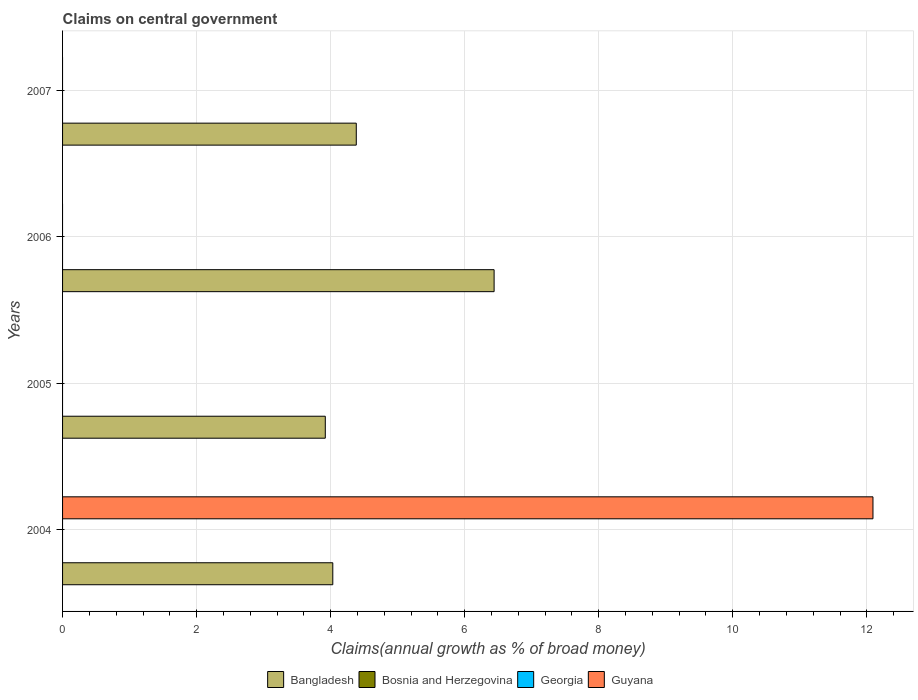How many bars are there on the 1st tick from the top?
Offer a terse response. 1. What is the label of the 2nd group of bars from the top?
Your response must be concise. 2006. In how many cases, is the number of bars for a given year not equal to the number of legend labels?
Provide a short and direct response. 4. What is the percentage of broad money claimed on centeral government in Georgia in 2004?
Provide a succinct answer. 0. Across all years, what is the maximum percentage of broad money claimed on centeral government in Bangladesh?
Provide a short and direct response. 6.44. Across all years, what is the minimum percentage of broad money claimed on centeral government in Bangladesh?
Provide a succinct answer. 3.92. What is the total percentage of broad money claimed on centeral government in Bangladesh in the graph?
Your answer should be very brief. 18.77. What is the difference between the percentage of broad money claimed on centeral government in Bangladesh in 2006 and that in 2007?
Your answer should be compact. 2.06. What is the average percentage of broad money claimed on centeral government in Bangladesh per year?
Give a very brief answer. 4.69. What is the ratio of the percentage of broad money claimed on centeral government in Bangladesh in 2004 to that in 2005?
Your response must be concise. 1.03. What is the difference between the highest and the second highest percentage of broad money claimed on centeral government in Bangladesh?
Provide a succinct answer. 2.06. What is the difference between the highest and the lowest percentage of broad money claimed on centeral government in Guyana?
Give a very brief answer. 12.09. In how many years, is the percentage of broad money claimed on centeral government in Bangladesh greater than the average percentage of broad money claimed on centeral government in Bangladesh taken over all years?
Provide a short and direct response. 1. Is the sum of the percentage of broad money claimed on centeral government in Bangladesh in 2005 and 2006 greater than the maximum percentage of broad money claimed on centeral government in Bosnia and Herzegovina across all years?
Offer a very short reply. Yes. Is it the case that in every year, the sum of the percentage of broad money claimed on centeral government in Guyana and percentage of broad money claimed on centeral government in Georgia is greater than the percentage of broad money claimed on centeral government in Bosnia and Herzegovina?
Ensure brevity in your answer.  No. How many bars are there?
Provide a short and direct response. 5. Are all the bars in the graph horizontal?
Your answer should be compact. Yes. How many years are there in the graph?
Offer a terse response. 4. Are the values on the major ticks of X-axis written in scientific E-notation?
Your response must be concise. No. Does the graph contain any zero values?
Offer a very short reply. Yes. Does the graph contain grids?
Provide a succinct answer. Yes. How many legend labels are there?
Ensure brevity in your answer.  4. How are the legend labels stacked?
Provide a succinct answer. Horizontal. What is the title of the graph?
Your response must be concise. Claims on central government. What is the label or title of the X-axis?
Provide a succinct answer. Claims(annual growth as % of broad money). What is the Claims(annual growth as % of broad money) of Bangladesh in 2004?
Offer a terse response. 4.03. What is the Claims(annual growth as % of broad money) in Bosnia and Herzegovina in 2004?
Your answer should be compact. 0. What is the Claims(annual growth as % of broad money) in Guyana in 2004?
Your response must be concise. 12.09. What is the Claims(annual growth as % of broad money) of Bangladesh in 2005?
Offer a terse response. 3.92. What is the Claims(annual growth as % of broad money) in Georgia in 2005?
Make the answer very short. 0. What is the Claims(annual growth as % of broad money) in Guyana in 2005?
Provide a short and direct response. 0. What is the Claims(annual growth as % of broad money) in Bangladesh in 2006?
Offer a terse response. 6.44. What is the Claims(annual growth as % of broad money) in Bosnia and Herzegovina in 2006?
Your response must be concise. 0. What is the Claims(annual growth as % of broad money) in Georgia in 2006?
Provide a succinct answer. 0. What is the Claims(annual growth as % of broad money) in Guyana in 2006?
Your response must be concise. 0. What is the Claims(annual growth as % of broad money) in Bangladesh in 2007?
Provide a succinct answer. 4.38. What is the Claims(annual growth as % of broad money) of Guyana in 2007?
Offer a very short reply. 0. Across all years, what is the maximum Claims(annual growth as % of broad money) in Bangladesh?
Keep it short and to the point. 6.44. Across all years, what is the maximum Claims(annual growth as % of broad money) in Guyana?
Provide a succinct answer. 12.09. Across all years, what is the minimum Claims(annual growth as % of broad money) in Bangladesh?
Offer a terse response. 3.92. Across all years, what is the minimum Claims(annual growth as % of broad money) of Guyana?
Make the answer very short. 0. What is the total Claims(annual growth as % of broad money) of Bangladesh in the graph?
Ensure brevity in your answer.  18.77. What is the total Claims(annual growth as % of broad money) of Guyana in the graph?
Offer a very short reply. 12.09. What is the difference between the Claims(annual growth as % of broad money) of Bangladesh in 2004 and that in 2005?
Give a very brief answer. 0.11. What is the difference between the Claims(annual growth as % of broad money) in Bangladesh in 2004 and that in 2006?
Make the answer very short. -2.41. What is the difference between the Claims(annual growth as % of broad money) of Bangladesh in 2004 and that in 2007?
Offer a terse response. -0.35. What is the difference between the Claims(annual growth as % of broad money) in Bangladesh in 2005 and that in 2006?
Your answer should be compact. -2.52. What is the difference between the Claims(annual growth as % of broad money) of Bangladesh in 2005 and that in 2007?
Provide a short and direct response. -0.46. What is the difference between the Claims(annual growth as % of broad money) in Bangladesh in 2006 and that in 2007?
Offer a terse response. 2.06. What is the average Claims(annual growth as % of broad money) in Bangladesh per year?
Ensure brevity in your answer.  4.69. What is the average Claims(annual growth as % of broad money) in Bosnia and Herzegovina per year?
Your response must be concise. 0. What is the average Claims(annual growth as % of broad money) in Guyana per year?
Ensure brevity in your answer.  3.02. In the year 2004, what is the difference between the Claims(annual growth as % of broad money) in Bangladesh and Claims(annual growth as % of broad money) in Guyana?
Provide a short and direct response. -8.06. What is the ratio of the Claims(annual growth as % of broad money) in Bangladesh in 2004 to that in 2005?
Ensure brevity in your answer.  1.03. What is the ratio of the Claims(annual growth as % of broad money) of Bangladesh in 2004 to that in 2006?
Provide a succinct answer. 0.63. What is the ratio of the Claims(annual growth as % of broad money) of Bangladesh in 2004 to that in 2007?
Provide a short and direct response. 0.92. What is the ratio of the Claims(annual growth as % of broad money) of Bangladesh in 2005 to that in 2006?
Your response must be concise. 0.61. What is the ratio of the Claims(annual growth as % of broad money) in Bangladesh in 2005 to that in 2007?
Offer a terse response. 0.89. What is the ratio of the Claims(annual growth as % of broad money) of Bangladesh in 2006 to that in 2007?
Keep it short and to the point. 1.47. What is the difference between the highest and the second highest Claims(annual growth as % of broad money) of Bangladesh?
Offer a terse response. 2.06. What is the difference between the highest and the lowest Claims(annual growth as % of broad money) of Bangladesh?
Offer a terse response. 2.52. What is the difference between the highest and the lowest Claims(annual growth as % of broad money) in Guyana?
Your response must be concise. 12.09. 